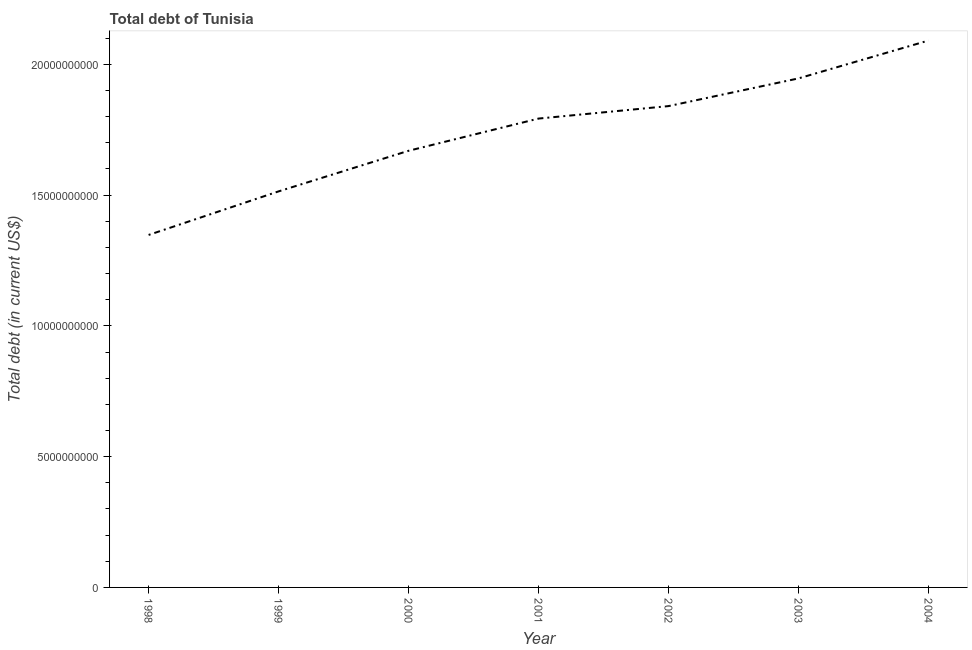What is the total debt in 2004?
Make the answer very short. 2.09e+1. Across all years, what is the maximum total debt?
Make the answer very short. 2.09e+1. Across all years, what is the minimum total debt?
Offer a terse response. 1.35e+1. What is the sum of the total debt?
Ensure brevity in your answer.  1.22e+11. What is the difference between the total debt in 1999 and 2000?
Give a very brief answer. -1.55e+09. What is the average total debt per year?
Offer a very short reply. 1.74e+1. What is the median total debt?
Keep it short and to the point. 1.79e+1. What is the ratio of the total debt in 2003 to that in 2004?
Your answer should be compact. 0.93. Is the total debt in 1998 less than that in 2000?
Offer a very short reply. Yes. Is the difference between the total debt in 1999 and 2001 greater than the difference between any two years?
Provide a short and direct response. No. What is the difference between the highest and the second highest total debt?
Your answer should be compact. 1.45e+09. Is the sum of the total debt in 2000 and 2003 greater than the maximum total debt across all years?
Make the answer very short. Yes. What is the difference between the highest and the lowest total debt?
Your answer should be compact. 7.43e+09. In how many years, is the total debt greater than the average total debt taken over all years?
Provide a short and direct response. 4. What is the difference between two consecutive major ticks on the Y-axis?
Your answer should be compact. 5.00e+09. Does the graph contain any zero values?
Your response must be concise. No. Does the graph contain grids?
Your answer should be very brief. No. What is the title of the graph?
Ensure brevity in your answer.  Total debt of Tunisia. What is the label or title of the X-axis?
Provide a succinct answer. Year. What is the label or title of the Y-axis?
Your response must be concise. Total debt (in current US$). What is the Total debt (in current US$) in 1998?
Your answer should be very brief. 1.35e+1. What is the Total debt (in current US$) in 1999?
Your answer should be compact. 1.51e+1. What is the Total debt (in current US$) of 2000?
Your answer should be very brief. 1.67e+1. What is the Total debt (in current US$) of 2001?
Keep it short and to the point. 1.79e+1. What is the Total debt (in current US$) of 2002?
Keep it short and to the point. 1.84e+1. What is the Total debt (in current US$) of 2003?
Provide a succinct answer. 1.95e+1. What is the Total debt (in current US$) of 2004?
Offer a very short reply. 2.09e+1. What is the difference between the Total debt (in current US$) in 1998 and 1999?
Make the answer very short. -1.67e+09. What is the difference between the Total debt (in current US$) in 1998 and 2000?
Ensure brevity in your answer.  -3.22e+09. What is the difference between the Total debt (in current US$) in 1998 and 2001?
Make the answer very short. -4.45e+09. What is the difference between the Total debt (in current US$) in 1998 and 2002?
Offer a very short reply. -4.93e+09. What is the difference between the Total debt (in current US$) in 1998 and 2003?
Your answer should be compact. -5.99e+09. What is the difference between the Total debt (in current US$) in 1998 and 2004?
Make the answer very short. -7.43e+09. What is the difference between the Total debt (in current US$) in 1999 and 2000?
Your response must be concise. -1.55e+09. What is the difference between the Total debt (in current US$) in 1999 and 2001?
Provide a short and direct response. -2.78e+09. What is the difference between the Total debt (in current US$) in 1999 and 2002?
Offer a terse response. -3.26e+09. What is the difference between the Total debt (in current US$) in 1999 and 2003?
Your answer should be compact. -4.32e+09. What is the difference between the Total debt (in current US$) in 1999 and 2004?
Provide a succinct answer. -5.77e+09. What is the difference between the Total debt (in current US$) in 2000 and 2001?
Give a very brief answer. -1.23e+09. What is the difference between the Total debt (in current US$) in 2000 and 2002?
Provide a short and direct response. -1.71e+09. What is the difference between the Total debt (in current US$) in 2000 and 2003?
Your answer should be compact. -2.77e+09. What is the difference between the Total debt (in current US$) in 2000 and 2004?
Make the answer very short. -4.21e+09. What is the difference between the Total debt (in current US$) in 2001 and 2002?
Ensure brevity in your answer.  -4.77e+08. What is the difference between the Total debt (in current US$) in 2001 and 2003?
Provide a succinct answer. -1.54e+09. What is the difference between the Total debt (in current US$) in 2001 and 2004?
Provide a succinct answer. -2.98e+09. What is the difference between the Total debt (in current US$) in 2002 and 2003?
Offer a terse response. -1.06e+09. What is the difference between the Total debt (in current US$) in 2002 and 2004?
Provide a succinct answer. -2.51e+09. What is the difference between the Total debt (in current US$) in 2003 and 2004?
Ensure brevity in your answer.  -1.45e+09. What is the ratio of the Total debt (in current US$) in 1998 to that in 1999?
Give a very brief answer. 0.89. What is the ratio of the Total debt (in current US$) in 1998 to that in 2000?
Make the answer very short. 0.81. What is the ratio of the Total debt (in current US$) in 1998 to that in 2001?
Make the answer very short. 0.75. What is the ratio of the Total debt (in current US$) in 1998 to that in 2002?
Your answer should be very brief. 0.73. What is the ratio of the Total debt (in current US$) in 1998 to that in 2003?
Your answer should be compact. 0.69. What is the ratio of the Total debt (in current US$) in 1998 to that in 2004?
Offer a terse response. 0.65. What is the ratio of the Total debt (in current US$) in 1999 to that in 2000?
Provide a succinct answer. 0.91. What is the ratio of the Total debt (in current US$) in 1999 to that in 2001?
Provide a short and direct response. 0.84. What is the ratio of the Total debt (in current US$) in 1999 to that in 2002?
Keep it short and to the point. 0.82. What is the ratio of the Total debt (in current US$) in 1999 to that in 2003?
Provide a succinct answer. 0.78. What is the ratio of the Total debt (in current US$) in 1999 to that in 2004?
Provide a succinct answer. 0.72. What is the ratio of the Total debt (in current US$) in 2000 to that in 2001?
Provide a succinct answer. 0.93. What is the ratio of the Total debt (in current US$) in 2000 to that in 2002?
Offer a very short reply. 0.91. What is the ratio of the Total debt (in current US$) in 2000 to that in 2003?
Provide a short and direct response. 0.86. What is the ratio of the Total debt (in current US$) in 2000 to that in 2004?
Make the answer very short. 0.8. What is the ratio of the Total debt (in current US$) in 2001 to that in 2003?
Your response must be concise. 0.92. What is the ratio of the Total debt (in current US$) in 2001 to that in 2004?
Offer a very short reply. 0.86. What is the ratio of the Total debt (in current US$) in 2002 to that in 2003?
Offer a terse response. 0.95. What is the ratio of the Total debt (in current US$) in 2003 to that in 2004?
Give a very brief answer. 0.93. 